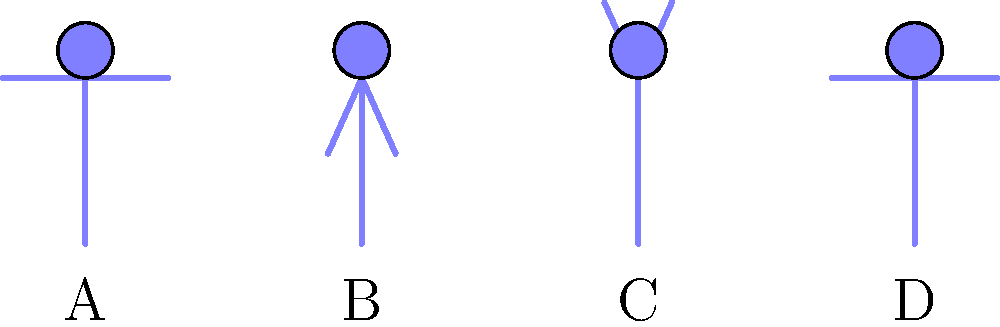In a group therapy session, you observe four patients (A, B, C, and D) standing as depicted in the image. Based on their body language, which patient is likely exhibiting the most open and receptive posture? To analyze the body language and posture of the individuals in this scenario, let's examine each patient step-by-step:

1. Patient A:
   - Standing straight with arms by their sides
   - Neutral posture, neither closed nor particularly open

2. Patient B:
   - Arms slightly angled inwards
   - This posture suggests a somewhat closed or defensive stance

3. Patient C:
   - Arms slightly angled outwards
   - This posture indicates openness and receptiveness

4. Patient D:
   - Standing straight with arms by their sides
   - Similar to Patient A, neutral posture

In body language analysis, open arm positions typically indicate receptiveness and engagement. Conversely, arms angled inwards or crossed can suggest defensiveness or discomfort.

Patient C's outward arm angle creates the most open silhouette among the four individuals. This posture is often associated with confidence, approachability, and willingness to engage in conversation or therapy.

Patients A and D, while not closed off, are in neutral positions that don't particularly signal openness or receptiveness.

Patient B's inward arm angle suggests the least open posture, potentially indicating some discomfort or reluctance in the therapy setting.
Answer: Patient C 